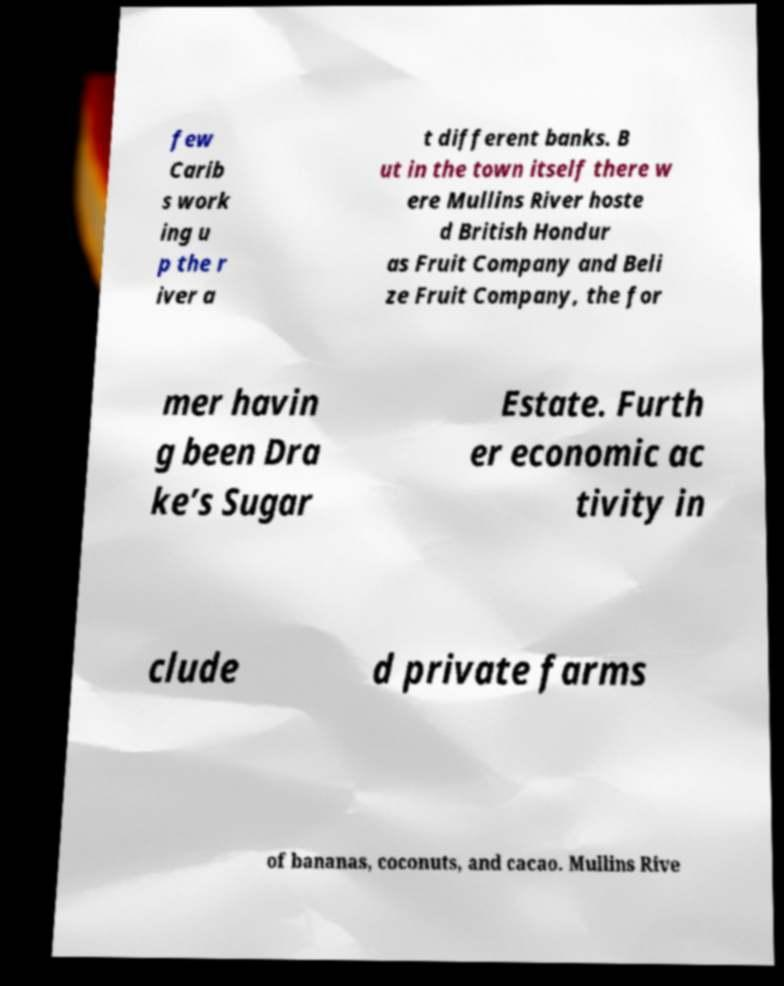Can you read and provide the text displayed in the image?This photo seems to have some interesting text. Can you extract and type it out for me? few Carib s work ing u p the r iver a t different banks. B ut in the town itself there w ere Mullins River hoste d British Hondur as Fruit Company and Beli ze Fruit Company, the for mer havin g been Dra ke’s Sugar Estate. Furth er economic ac tivity in clude d private farms of bananas, coconuts, and cacao. Mullins Rive 